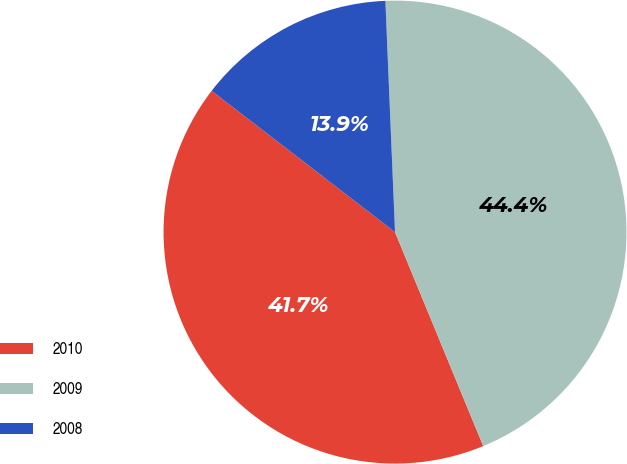Convert chart. <chart><loc_0><loc_0><loc_500><loc_500><pie_chart><fcel>2010<fcel>2009<fcel>2008<nl><fcel>41.67%<fcel>44.44%<fcel>13.89%<nl></chart> 